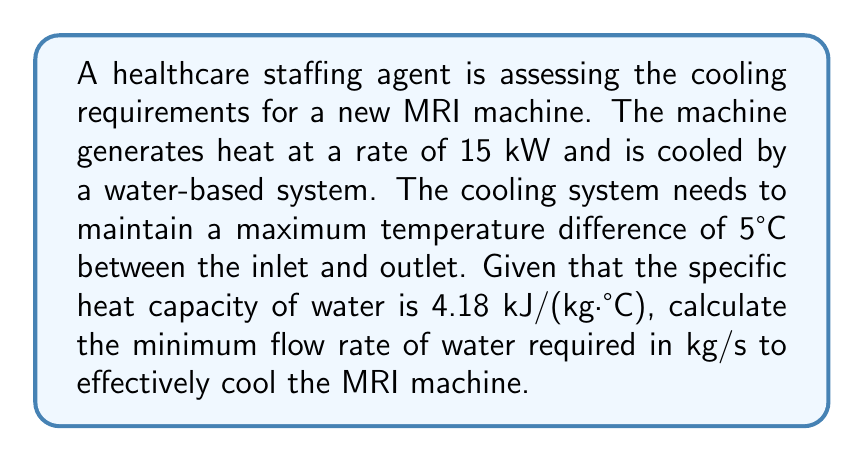Show me your answer to this math problem. To solve this problem, we'll use the heat transfer equation:

$$Q = \dot{m} c_p \Delta T$$

Where:
$Q$ = Heat transfer rate (kW)
$\dot{m}$ = Mass flow rate of water (kg/s)
$c_p$ = Specific heat capacity of water (kJ/(kg·°C))
$\Delta T$ = Temperature difference (°C)

Given:
$Q = 15 \text{ kW} = 15 \text{ kJ/s}$
$c_p = 4.18 \text{ kJ/(kg·°C)}$
$\Delta T = 5°C$

Step 1: Rearrange the equation to solve for $\dot{m}$:
$$\dot{m} = \frac{Q}{c_p \Delta T}$$

Step 2: Substitute the known values:
$$\dot{m} = \frac{15 \text{ kJ/s}}{4.18 \text{ kJ/(kg·°C)} \times 5°C}$$

Step 3: Calculate the result:
$$\dot{m} = \frac{15}{4.18 \times 5} = 0.7177 \text{ kg/s}$$

Therefore, the minimum flow rate of water required is approximately 0.7177 kg/s.
Answer: 0.7177 kg/s 